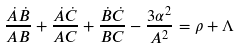<formula> <loc_0><loc_0><loc_500><loc_500>\frac { \dot { A } \dot { B } } { A B } + \frac { \dot { A } \dot { C } } { A C } + \frac { \dot { B } \dot { C } } { B C } - \frac { 3 \alpha ^ { 2 } } { A ^ { 2 } } = \rho + \Lambda</formula> 